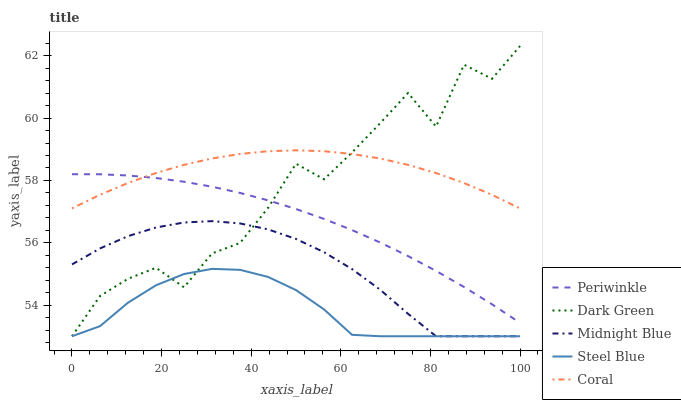Does Steel Blue have the minimum area under the curve?
Answer yes or no. Yes. Does Coral have the maximum area under the curve?
Answer yes or no. Yes. Does Periwinkle have the minimum area under the curve?
Answer yes or no. No. Does Periwinkle have the maximum area under the curve?
Answer yes or no. No. Is Periwinkle the smoothest?
Answer yes or no. Yes. Is Dark Green the roughest?
Answer yes or no. Yes. Is Steel Blue the smoothest?
Answer yes or no. No. Is Steel Blue the roughest?
Answer yes or no. No. Does Steel Blue have the lowest value?
Answer yes or no. Yes. Does Periwinkle have the lowest value?
Answer yes or no. No. Does Dark Green have the highest value?
Answer yes or no. Yes. Does Periwinkle have the highest value?
Answer yes or no. No. Is Steel Blue less than Periwinkle?
Answer yes or no. Yes. Is Coral greater than Midnight Blue?
Answer yes or no. Yes. Does Midnight Blue intersect Steel Blue?
Answer yes or no. Yes. Is Midnight Blue less than Steel Blue?
Answer yes or no. No. Is Midnight Blue greater than Steel Blue?
Answer yes or no. No. Does Steel Blue intersect Periwinkle?
Answer yes or no. No. 